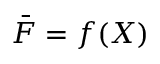Convert formula to latex. <formula><loc_0><loc_0><loc_500><loc_500>\bar { F } = f ( X )</formula> 